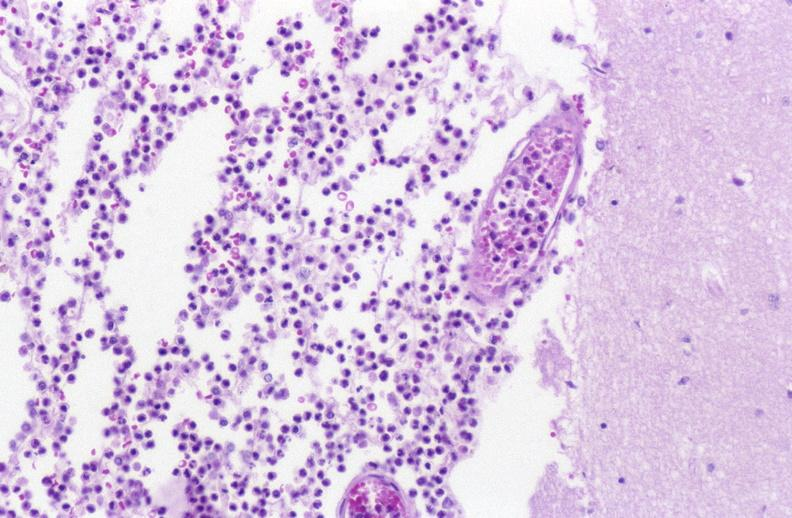what does this image show?
Answer the question using a single word or phrase. Bacterial meningitis 